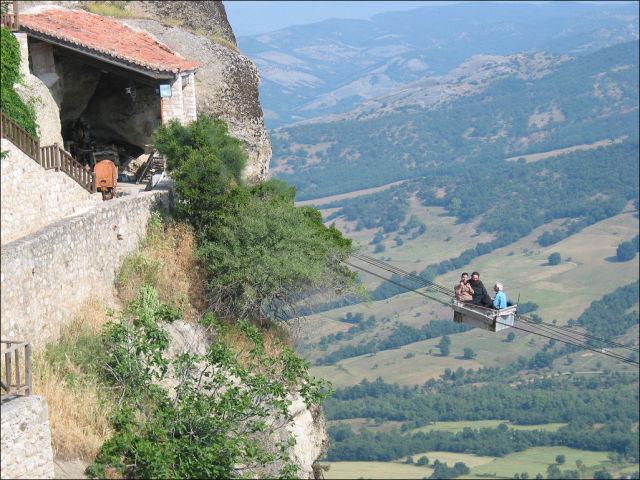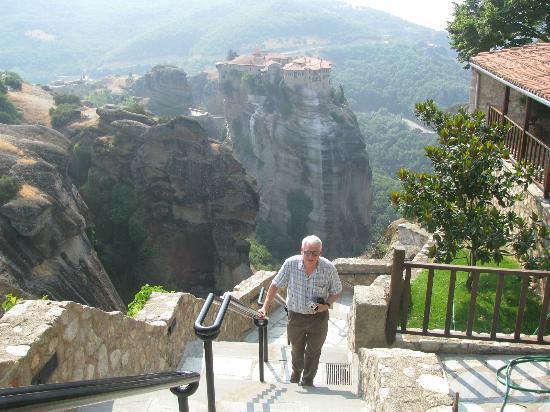The first image is the image on the left, the second image is the image on the right. Assess this claim about the two images: "There are stairs in the image on the right". Correct or not? Answer yes or no. Yes. 